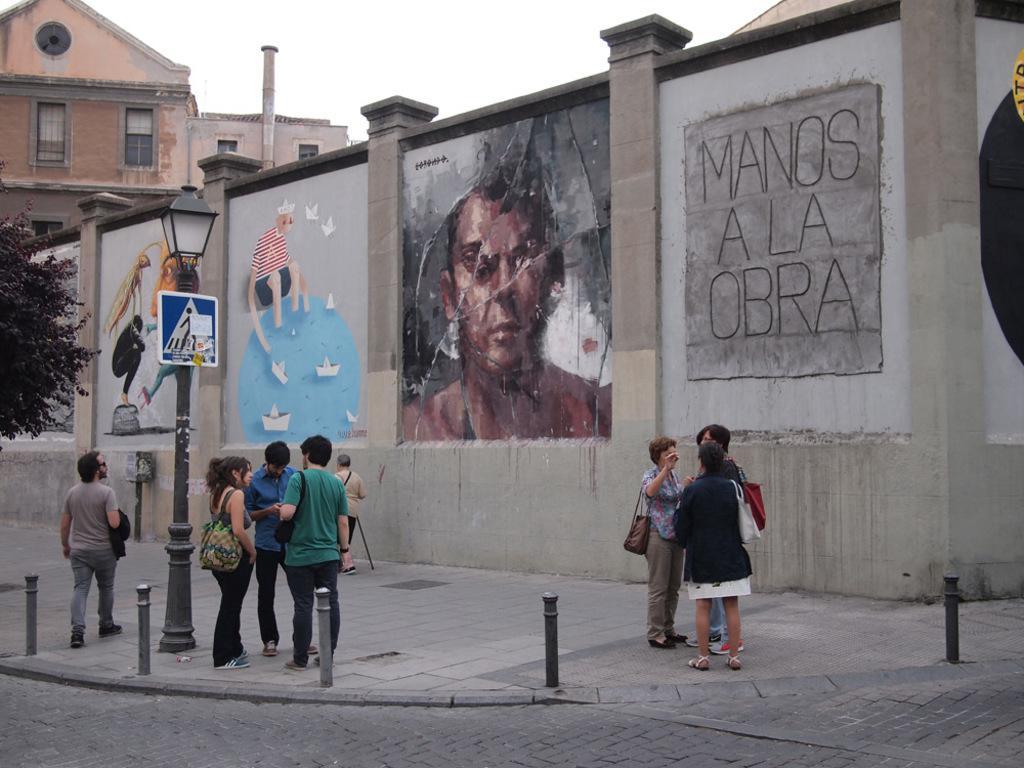Could you give a brief overview of what you see in this image? In this image I can see the road, the sidewalk, few black colored poles, a sign board attached to the pole and few persons standing on the sidewalk. I can see a tree, a wall and few painting on the wall and a building. In the background I can see the sky. 